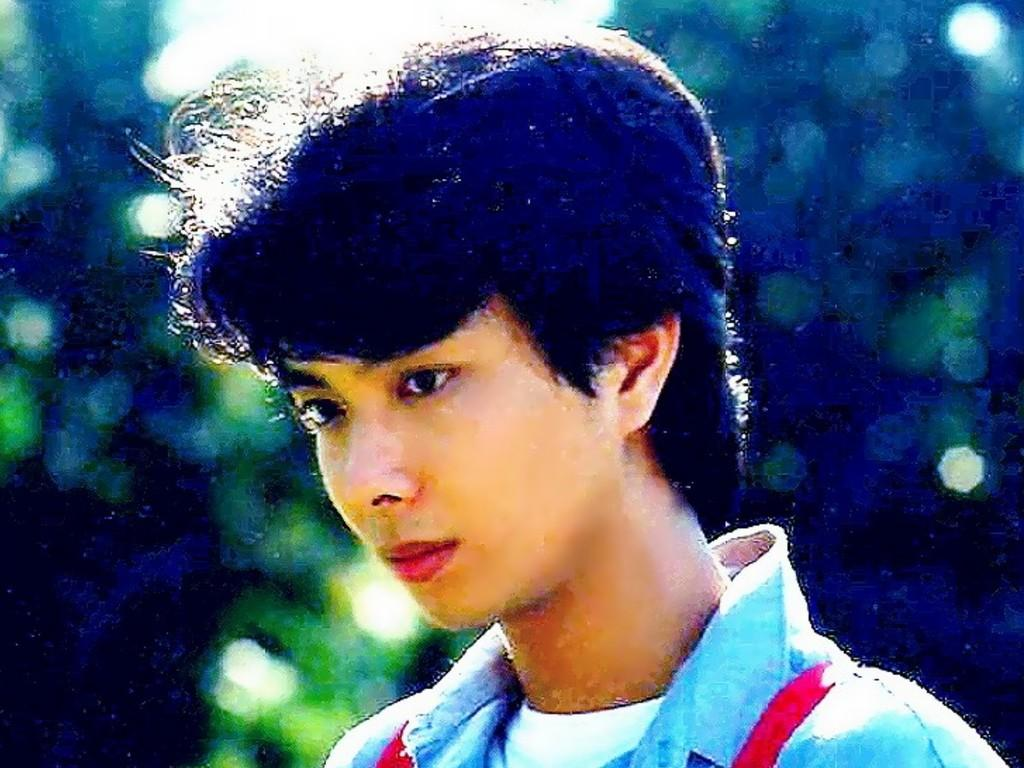Who is present in the image? There is a man in the picture. What is the man doing in the image? The man is standing in the image. In which direction is the man looking? The man is looking to the left in the image. What can be seen in the background of the image? There are trees in the background of the picture. What idea does the man have about the loss of the porter in the image? There is no mention of a porter or any loss in the image, so it is not possible to answer that question. 